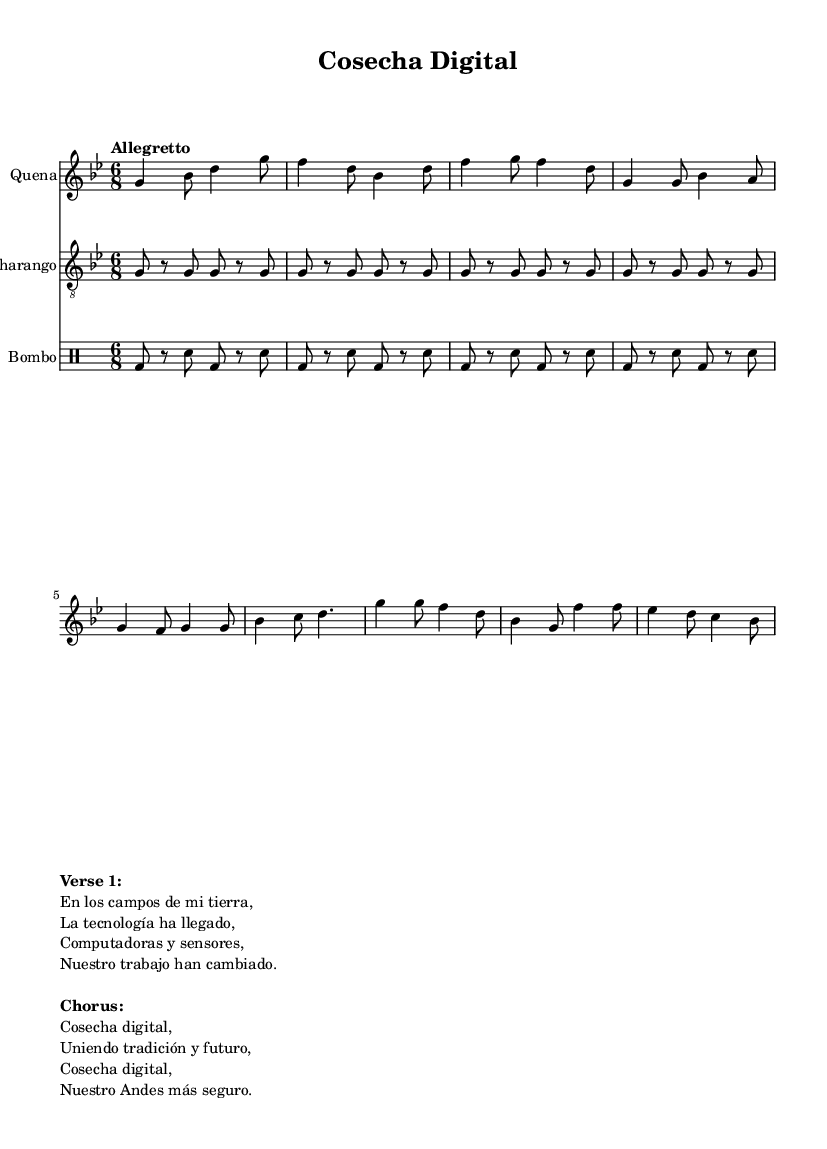What is the key signature of this music? The key signature of the music is indicated at the beginning of the score, and it shows that there are two flats. This corresponds to the key of G minor.
Answer: G minor What is the time signature of the piece? The time signature is found at the beginning of the score, displayed as 6/8. This indicates that there are six eighth notes per measure.
Answer: 6/8 What is the tempo marking for this music? The tempo marking, which is also provided at the beginning of the score, reads "Allegretto." This indicates a moderately fast tempo.
Answer: Allegretto How many measures are in the verse section? By examining the musical notation in the verse section from the score, we count the number of measures provided, which totals to four measures.
Answer: Four What is the function of the charango in this score? The charango appears as a simplified melodic line and is typically played alongside the quena. In the score, it plays a repetitive pattern that complements the main melody.
Answer: Melody What are the lyrics for the chorus? The lyrics for the chorus are listed in the markup section beneath the musical notation. Upon reviewing that text, the lyrics are: "Cosecha digital, Uniendo tradición y futuro, Cosecha digital, Nuestro Andes más seguro."
Answer: Cosecha digital, Uniendo tradición y futuro, Cosecha digital, Nuestro Andes más seguro What is the significance of the title "Cosecha Digital"? The title "Cosecha Digital" reflects the theme of the song, which celebrates the integration of digital technology in agriculture, highlighting both tradition and advancement within rural Andean communities.
Answer: Integration of digital technology in agriculture 